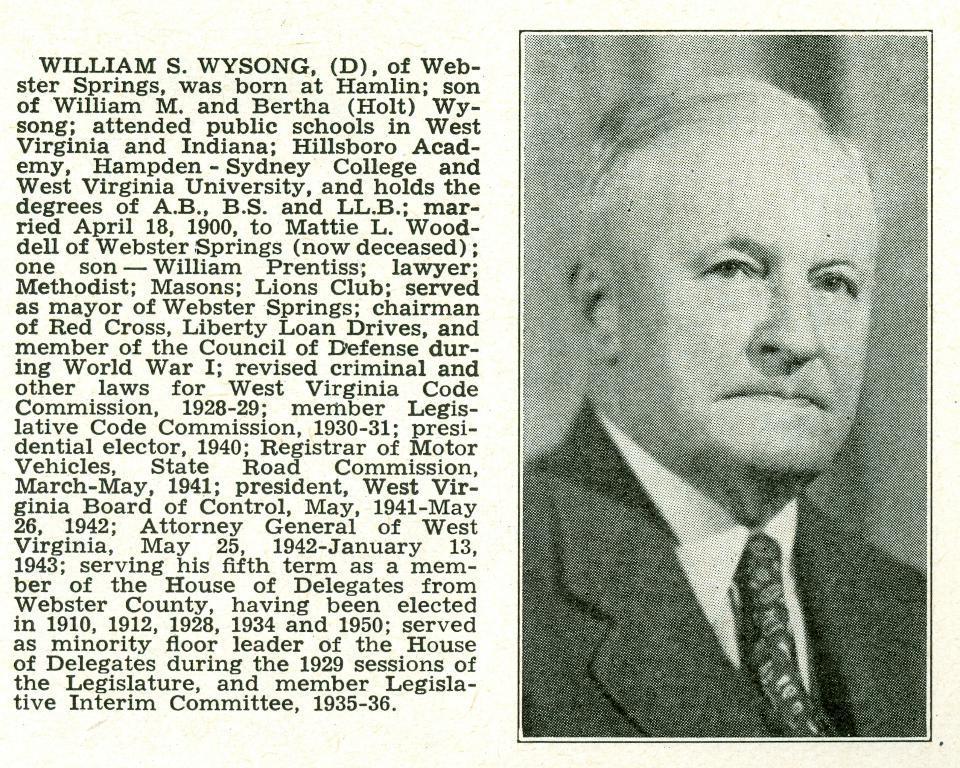In one or two sentences, can you explain what this image depicts? On the right side of the image we can see a person. On the right side of the image there is a text. 